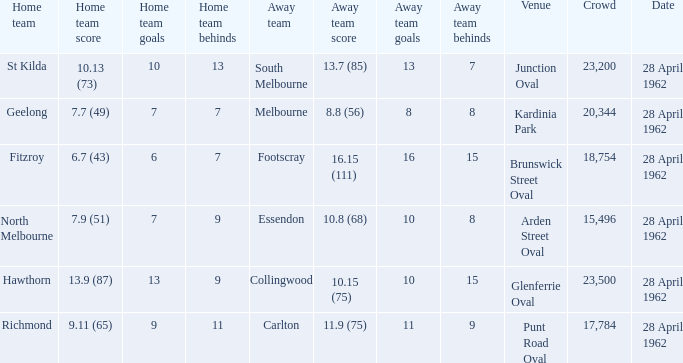15 (75)? Glenferrie Oval. 